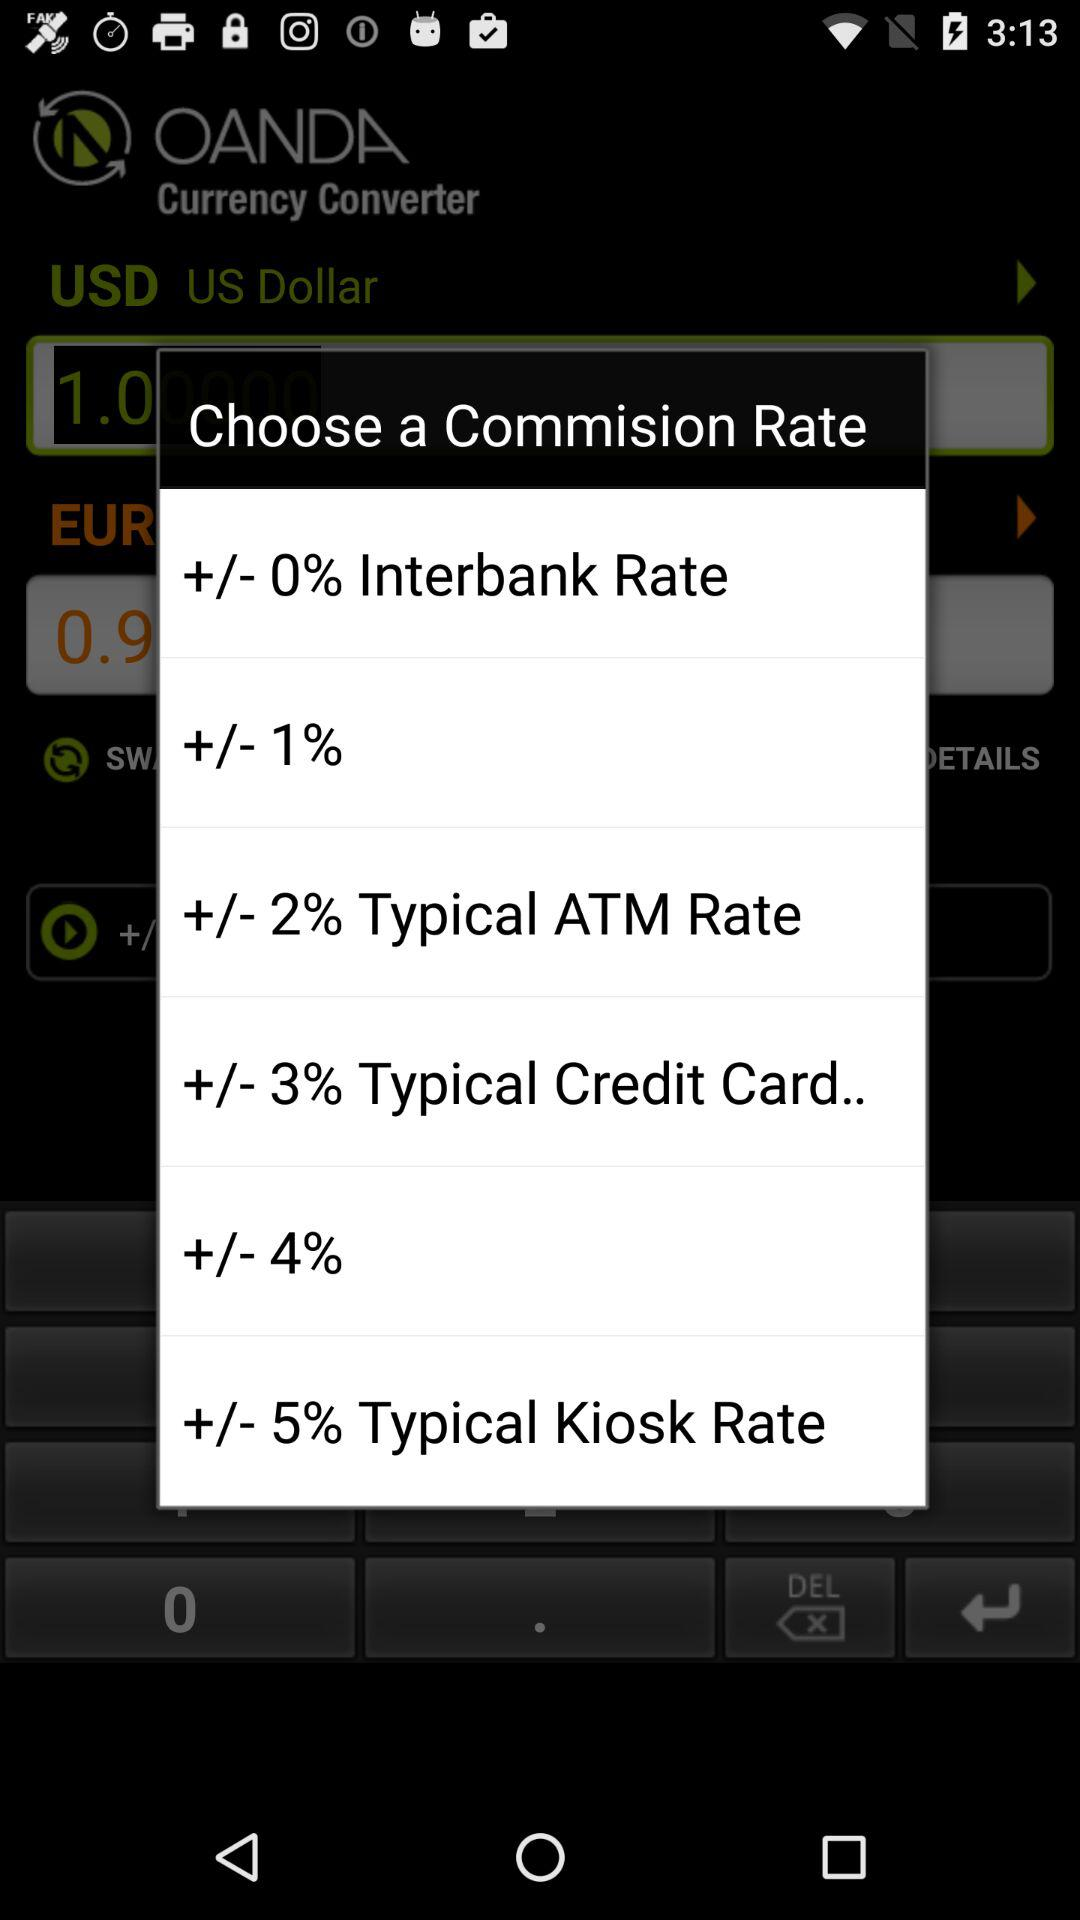What is the commission rate for the "Interbank rate"? The commission rate is "+/- 0%". 